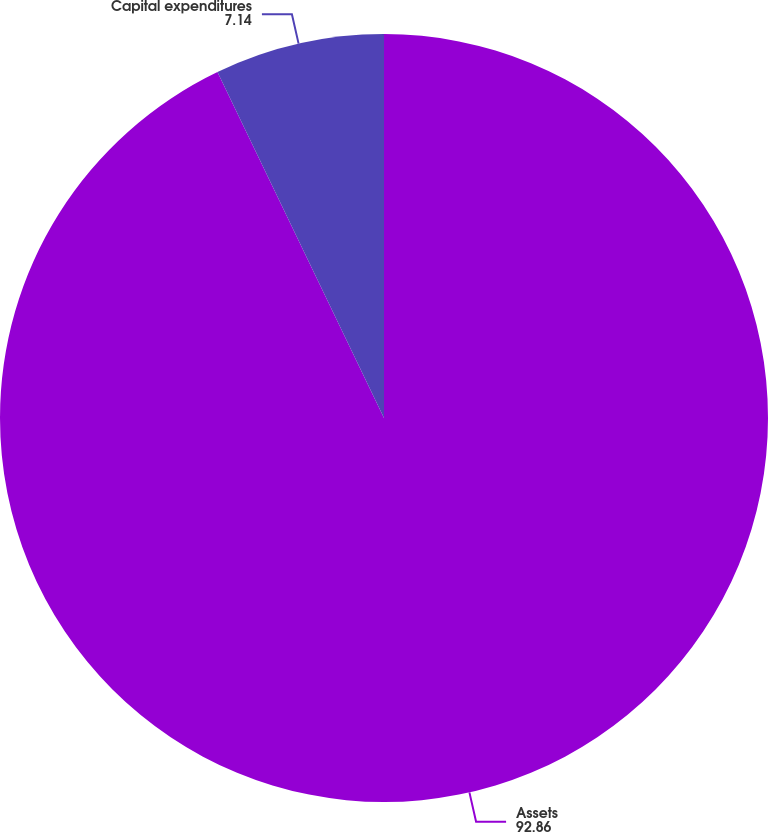Convert chart. <chart><loc_0><loc_0><loc_500><loc_500><pie_chart><fcel>Assets<fcel>Capital expenditures<nl><fcel>92.86%<fcel>7.14%<nl></chart> 